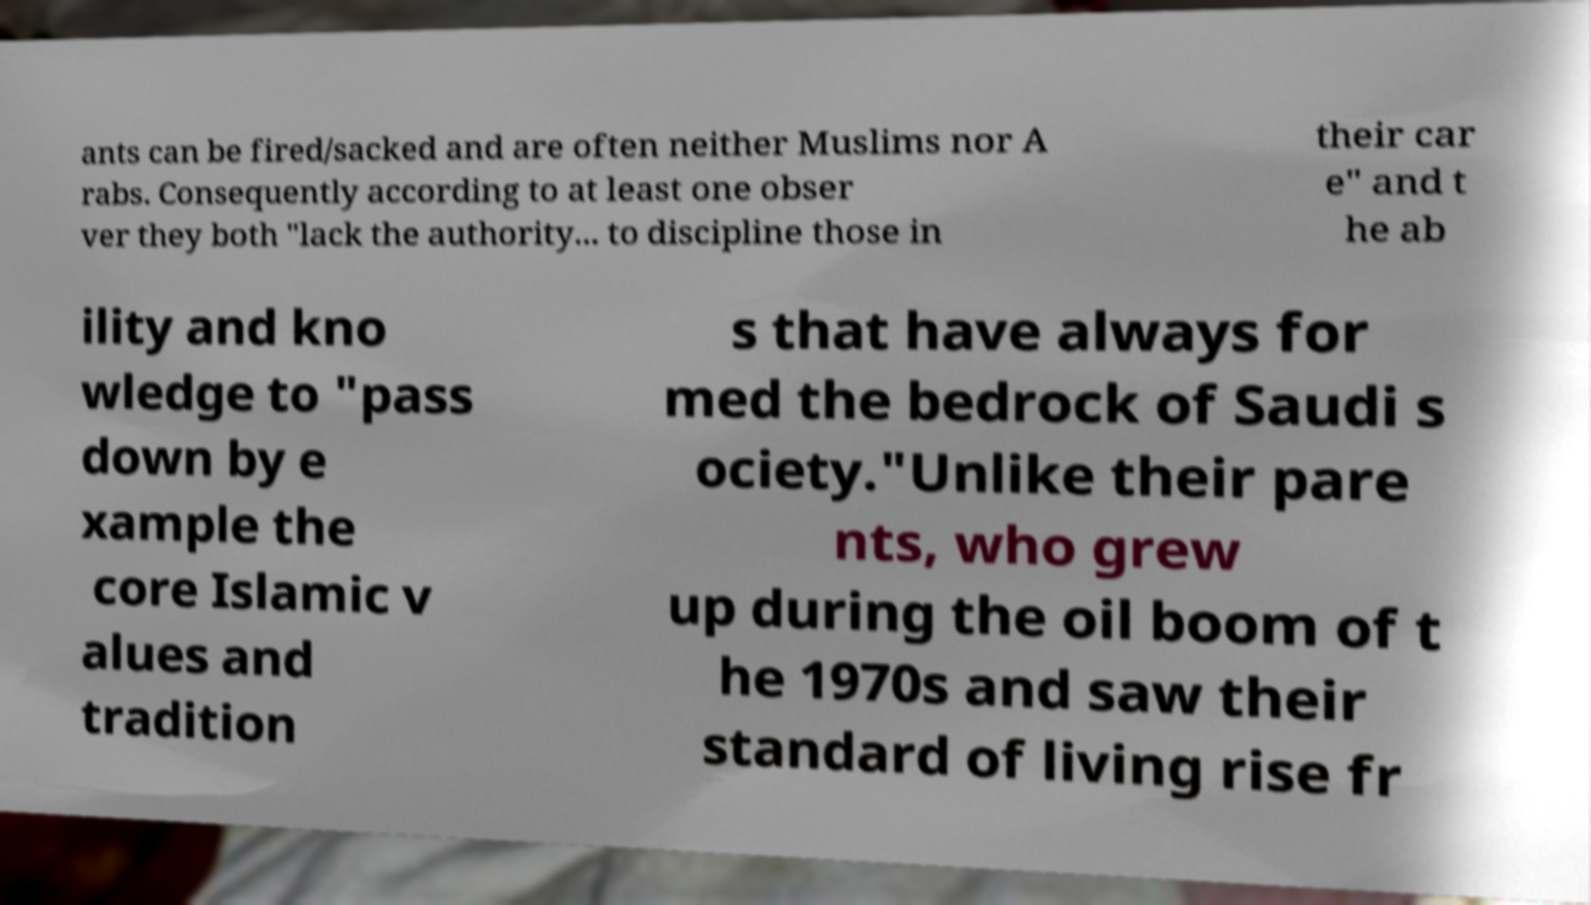There's text embedded in this image that I need extracted. Can you transcribe it verbatim? ants can be fired/sacked and are often neither Muslims nor A rabs. Consequently according to at least one obser ver they both "lack the authority... to discipline those in their car e" and t he ab ility and kno wledge to "pass down by e xample the core Islamic v alues and tradition s that have always for med the bedrock of Saudi s ociety."Unlike their pare nts, who grew up during the oil boom of t he 1970s and saw their standard of living rise fr 